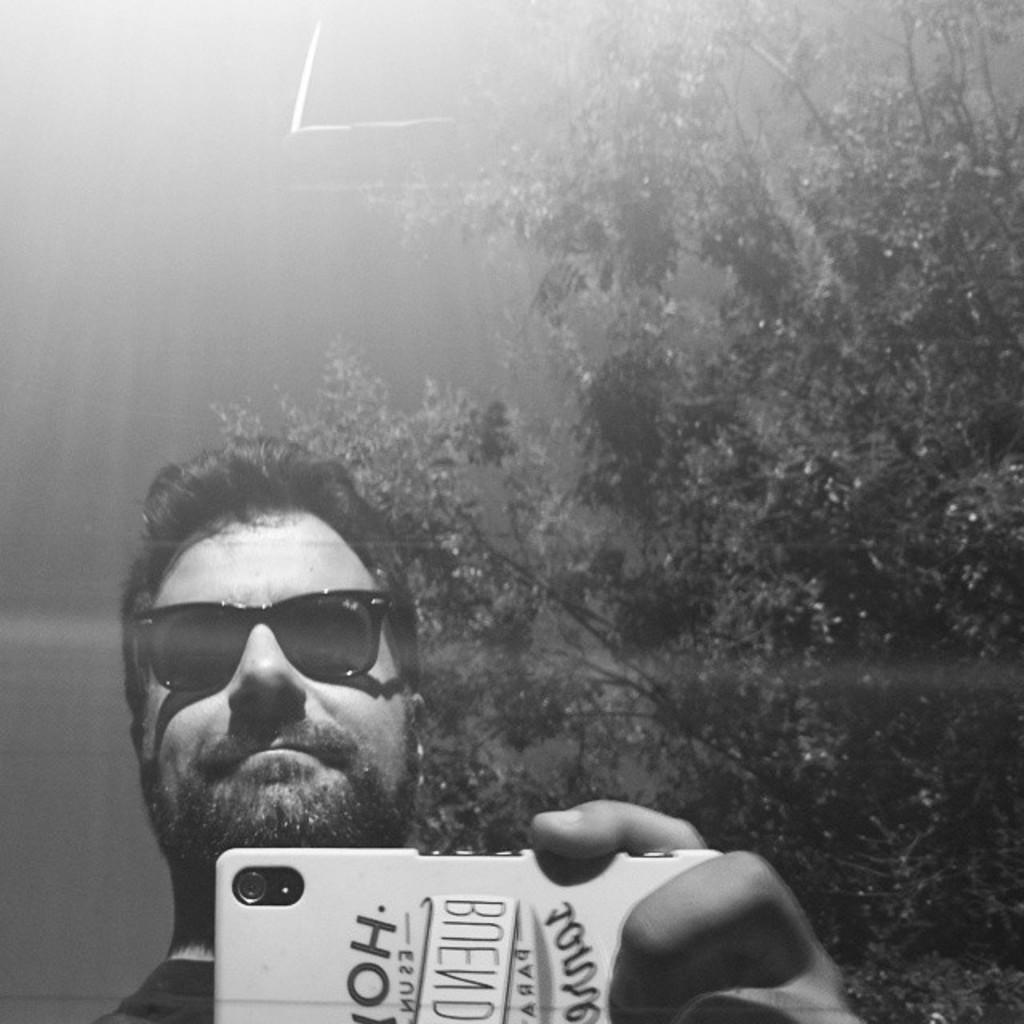Can you describe this image briefly? This is a black and white image, in this image a man holding mobile in his hands and wearing glasses, in the background there is a tree. 